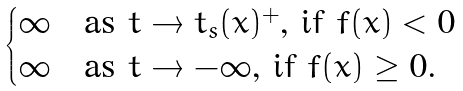Convert formula to latex. <formula><loc_0><loc_0><loc_500><loc_500>\begin{cases} \infty & \text {as $t \rightarrow t_{s}(x)^{+}$, if $f(x)<0$} \\ \infty & \text {as $t \rightarrow -\infty$, if $f(x)\geq0$.} \end{cases}</formula> 